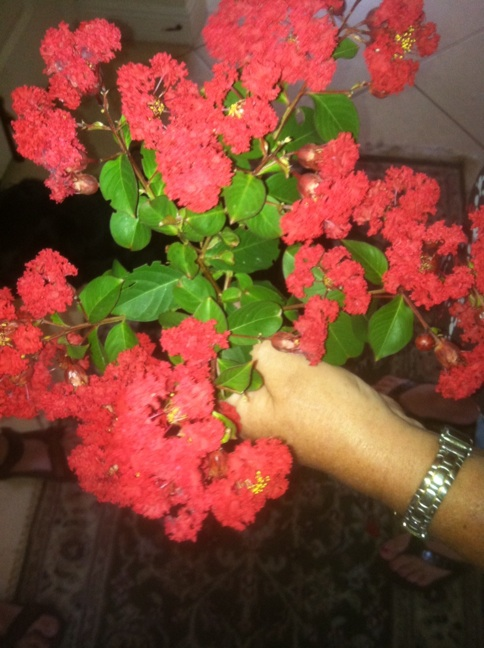Can you tell me what kind of flower this is? The flower in the image is a 'Lagerstroemia,' commonly known as 'crape myrtle.' These are popular for their vivid and extended blooms during the warmer months. Typically found in colors ranging from pink to deep red, they are a favorite in decorative landscaping due to their bright and lush clusters. 